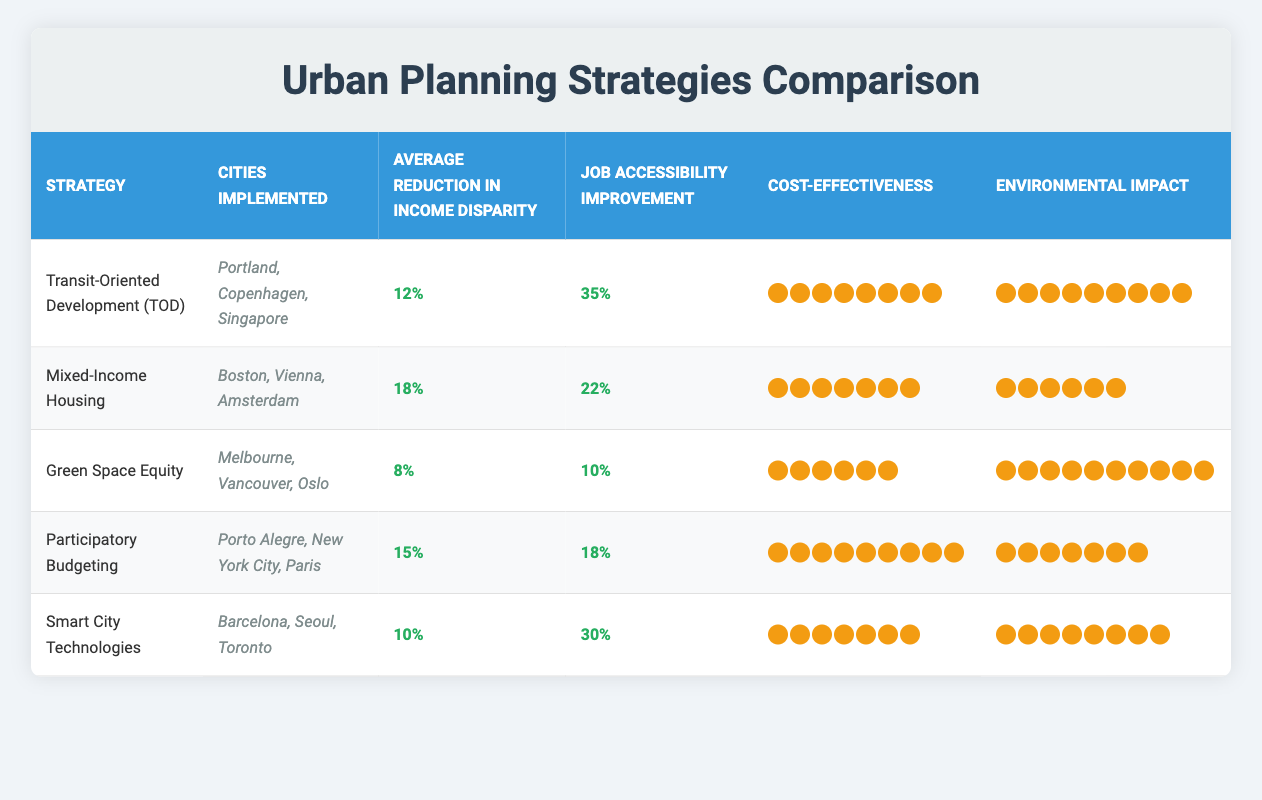What is the average reduction in income disparity for Mixed-Income Housing? The table states that Mixed-Income Housing has an average reduction in income disparity of 18%. To find this, we can directly refer to the corresponding row under "Average Reduction in Income Disparity."
Answer: 18% Which urban planning strategy has the highest job accessibility improvement? Looking at the "Job Accessibility Improvement" column, Transit-Oriented Development (TOD) has the highest percentage at 35%. Thus, we can conclude that TOD provides the most significant improvement in job accessibility.
Answer: Transit-Oriented Development (TOD) Is the environmental impact of Smart City Technologies greater than that of Green Space Equity? Checking both values, Smart City Technologies has an environmental impact rating of 8, while Green Space Equity has a rating of 10. Since 8 is less than 10, the statement is false.
Answer: No Which strategies have an average reduction in income disparity greater than 10%? We can compare the values in the "Average Reduction in Income Disparity" column: Mixed-Income Housing (18%), Transit-Oriented Development (TOD) (12%), and Participatory Budgeting (15%) all exceed 10%. Therefore, these strategies meet the condition.
Answer: Mixed-Income Housing, Transit-Oriented Development (TOD), Participatory Budgeting What is the total cost-effectiveness score for all urban planning strategies? The cost-effectiveness scores for each strategy are added together: 8 (TOD) + 7 (Mixed-Income Housing) + 6 (Green Space Equity) + 9 (Participatory Budgeting) + 7 (Smart City Technologies) equals 37. Thus, the total cost-effectiveness score is calculated as follows.
Answer: 37 